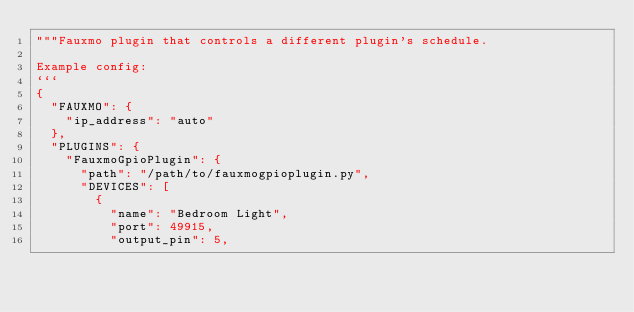Convert code to text. <code><loc_0><loc_0><loc_500><loc_500><_Python_>"""Fauxmo plugin that controls a different plugin's schedule.

Example config:
```
{
  "FAUXMO": {
    "ip_address": "auto"
  },
  "PLUGINS": {
    "FauxmoGpioPlugin": {
      "path": "/path/to/fauxmogpioplugin.py",
      "DEVICES": [
        {
          "name": "Bedroom Light",
          "port": 49915,
          "output_pin": 5,</code> 